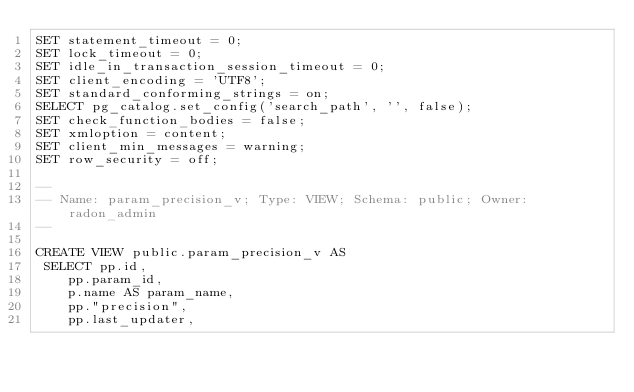<code> <loc_0><loc_0><loc_500><loc_500><_SQL_>SET statement_timeout = 0;
SET lock_timeout = 0;
SET idle_in_transaction_session_timeout = 0;
SET client_encoding = 'UTF8';
SET standard_conforming_strings = on;
SELECT pg_catalog.set_config('search_path', '', false);
SET check_function_bodies = false;
SET xmloption = content;
SET client_min_messages = warning;
SET row_security = off;

--
-- Name: param_precision_v; Type: VIEW; Schema: public; Owner: radon_admin
--

CREATE VIEW public.param_precision_v AS
 SELECT pp.id,
    pp.param_id,
    p.name AS param_name,
    pp."precision",
    pp.last_updater,</code> 